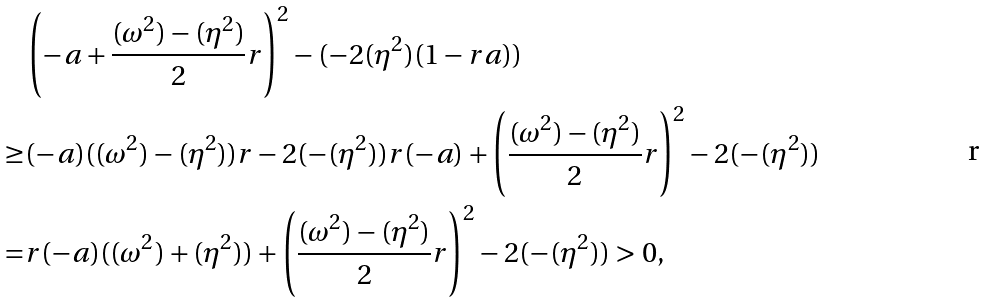Convert formula to latex. <formula><loc_0><loc_0><loc_500><loc_500>& \left ( - a + \frac { ( \omega ^ { 2 } ) - ( \eta ^ { 2 } ) } { 2 } r \right ) ^ { 2 } - ( - 2 ( \eta ^ { 2 } ) ( 1 - r a ) ) \\ \geq & ( - a ) ( ( \omega ^ { 2 } ) - ( \eta ^ { 2 } ) ) r - 2 ( - ( \eta ^ { 2 } ) ) r ( - a ) + \left ( \frac { ( \omega ^ { 2 } ) - ( \eta ^ { 2 } ) } { 2 } r \right ) ^ { 2 } - 2 ( - ( \eta ^ { 2 } ) ) \\ = & r ( - a ) ( ( \omega ^ { 2 } ) + ( \eta ^ { 2 } ) ) + \left ( \frac { ( \omega ^ { 2 } ) - ( \eta ^ { 2 } ) } { 2 } r \right ) ^ { 2 } - 2 ( - ( \eta ^ { 2 } ) ) > 0 ,</formula> 